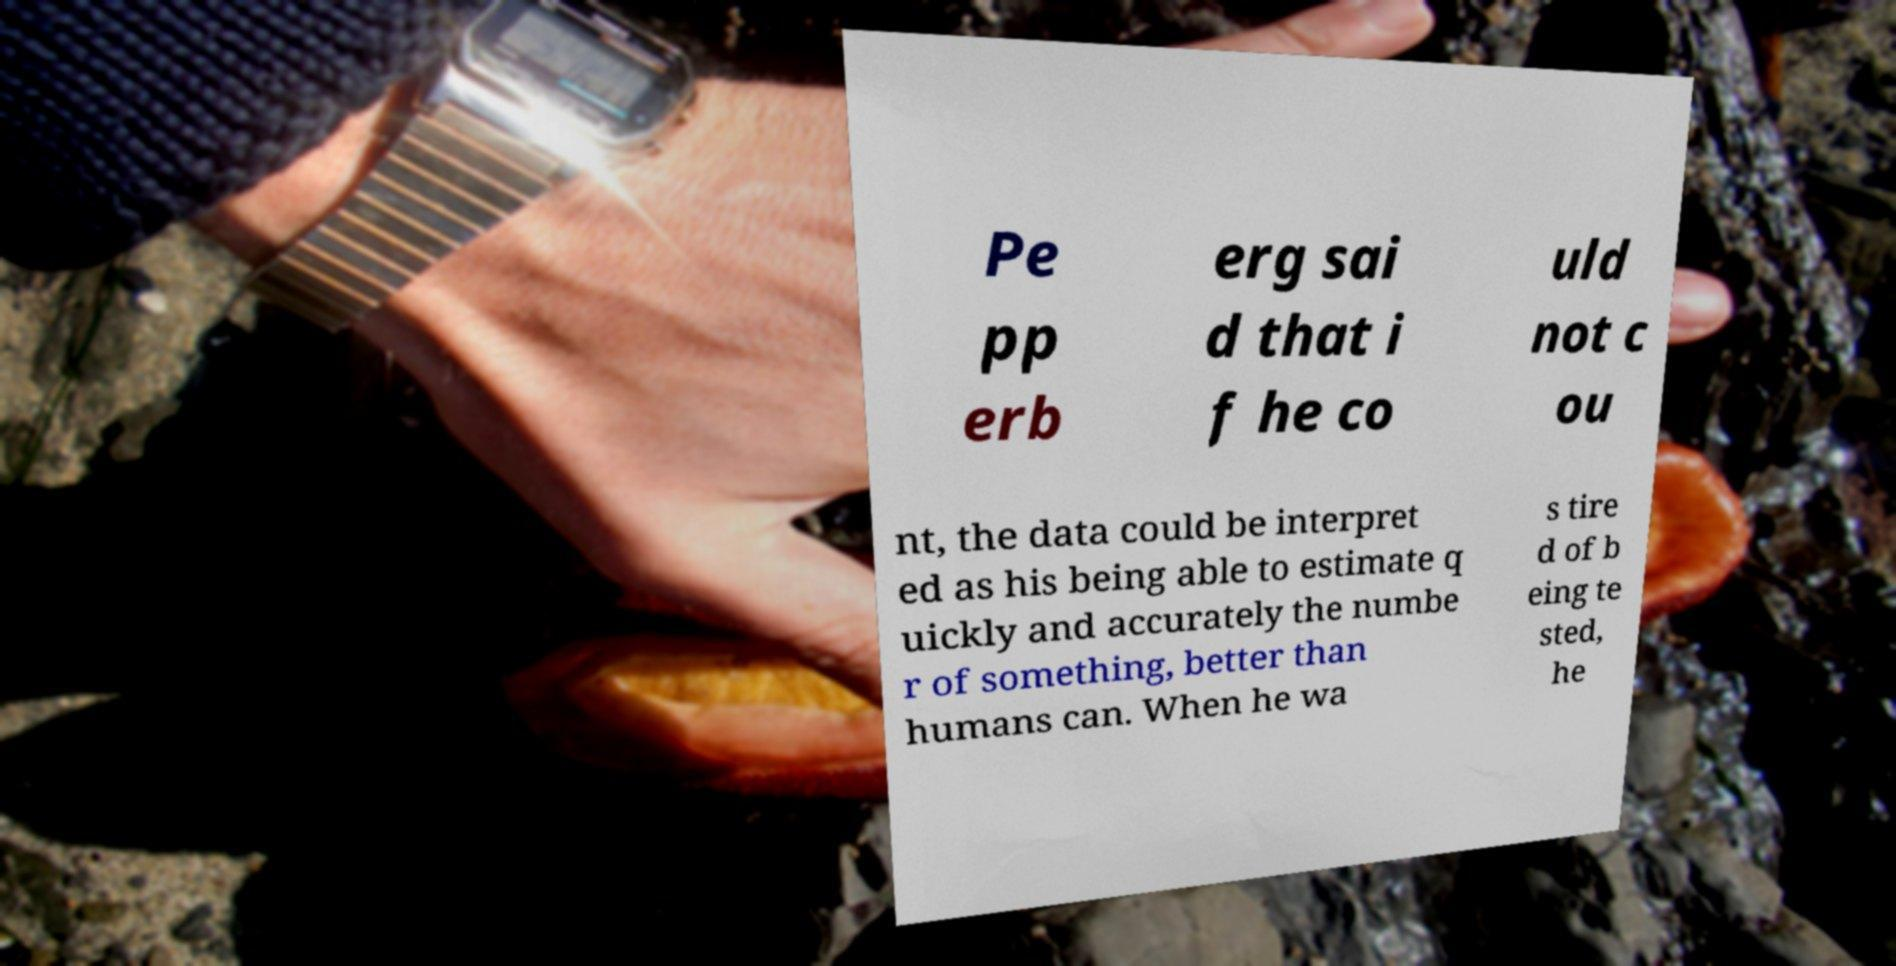Please read and relay the text visible in this image. What does it say? Pe pp erb erg sai d that i f he co uld not c ou nt, the data could be interpret ed as his being able to estimate q uickly and accurately the numbe r of something, better than humans can. When he wa s tire d of b eing te sted, he 